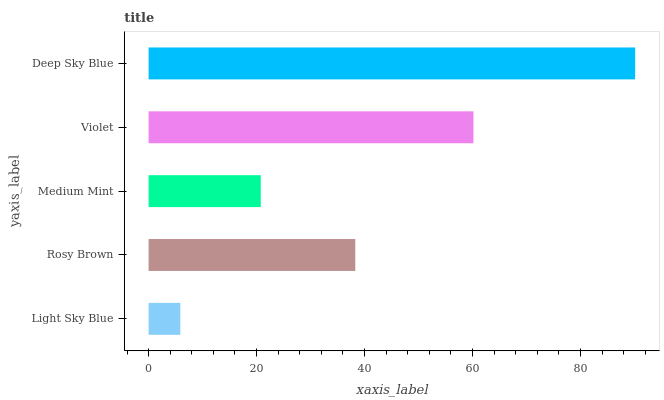Is Light Sky Blue the minimum?
Answer yes or no. Yes. Is Deep Sky Blue the maximum?
Answer yes or no. Yes. Is Rosy Brown the minimum?
Answer yes or no. No. Is Rosy Brown the maximum?
Answer yes or no. No. Is Rosy Brown greater than Light Sky Blue?
Answer yes or no. Yes. Is Light Sky Blue less than Rosy Brown?
Answer yes or no. Yes. Is Light Sky Blue greater than Rosy Brown?
Answer yes or no. No. Is Rosy Brown less than Light Sky Blue?
Answer yes or no. No. Is Rosy Brown the high median?
Answer yes or no. Yes. Is Rosy Brown the low median?
Answer yes or no. Yes. Is Violet the high median?
Answer yes or no. No. Is Deep Sky Blue the low median?
Answer yes or no. No. 